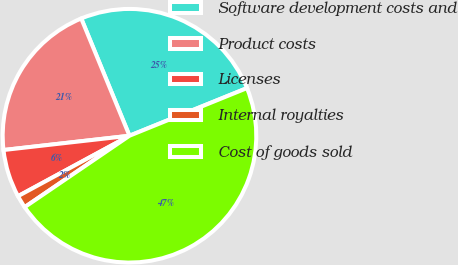<chart> <loc_0><loc_0><loc_500><loc_500><pie_chart><fcel>Software development costs and<fcel>Product costs<fcel>Licenses<fcel>Internal royalties<fcel>Cost of goods sold<nl><fcel>25.08%<fcel>20.58%<fcel>6.11%<fcel>1.61%<fcel>46.61%<nl></chart> 